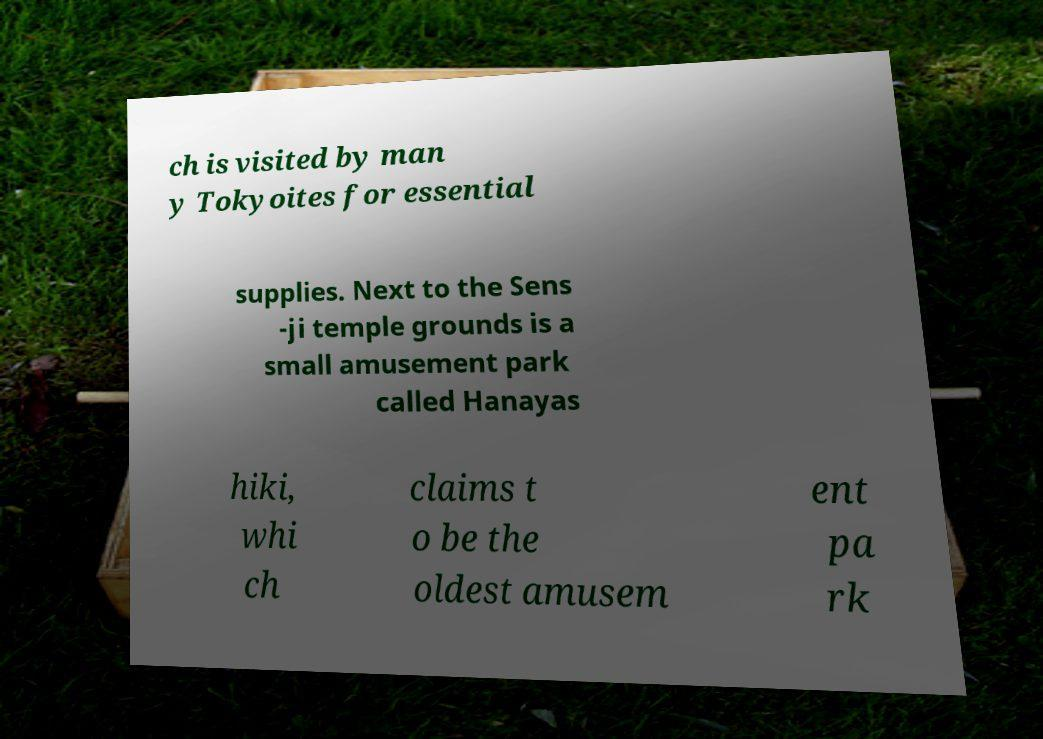Can you accurately transcribe the text from the provided image for me? ch is visited by man y Tokyoites for essential supplies. Next to the Sens -ji temple grounds is a small amusement park called Hanayas hiki, whi ch claims t o be the oldest amusem ent pa rk 